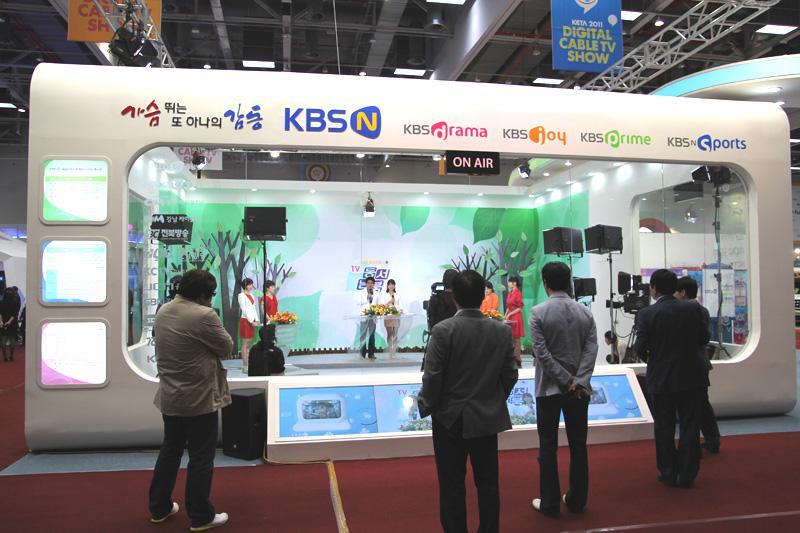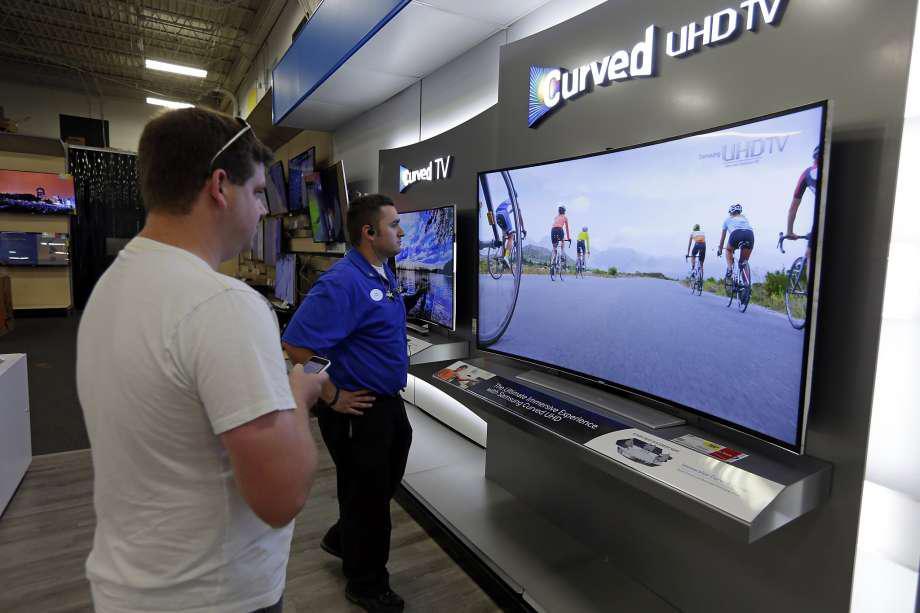The first image is the image on the left, the second image is the image on the right. Examine the images to the left and right. Is the description "In one image, one woman has one hand at the top of a big-screen TV and is gesturing toward it with the other hand." accurate? Answer yes or no. No. The first image is the image on the left, the second image is the image on the right. For the images displayed, is the sentence "In at least one image there is a woman standing to the right of a TV display showing it." factually correct? Answer yes or no. No. 